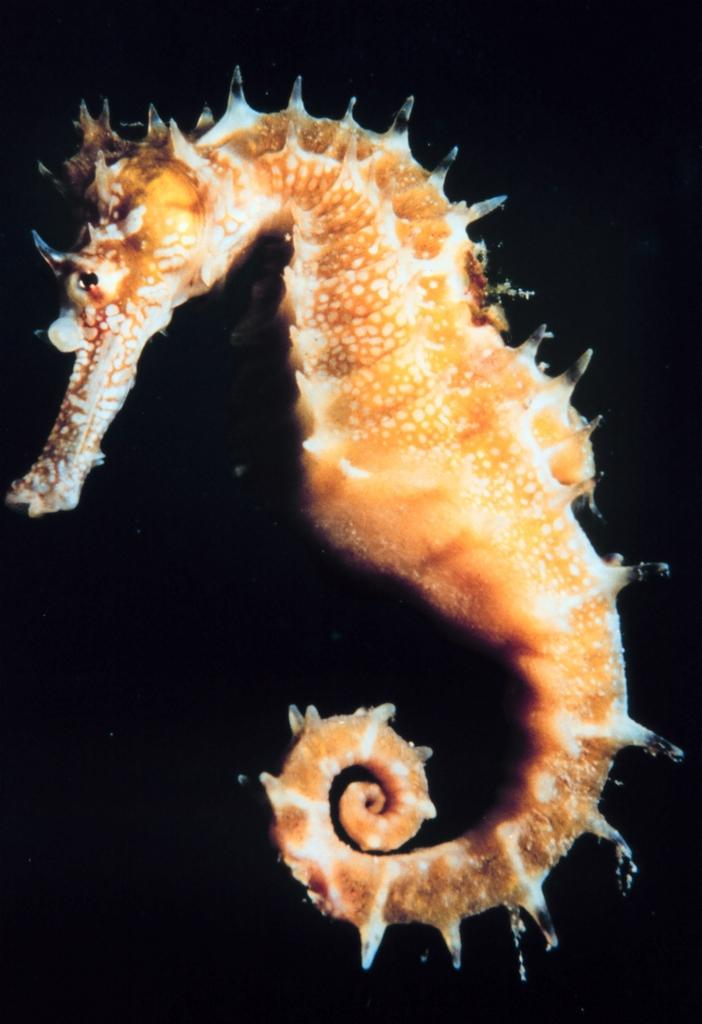What is the main subject of the image? There is a seahorse in the image. What can be observed about the background of the image? The background of the image is dark. What type of truck is visible in the image? There is no truck present in the image; it features a seahorse. How many ships can be seen in the image? There are no ships present in the image; it features a seahorse. 